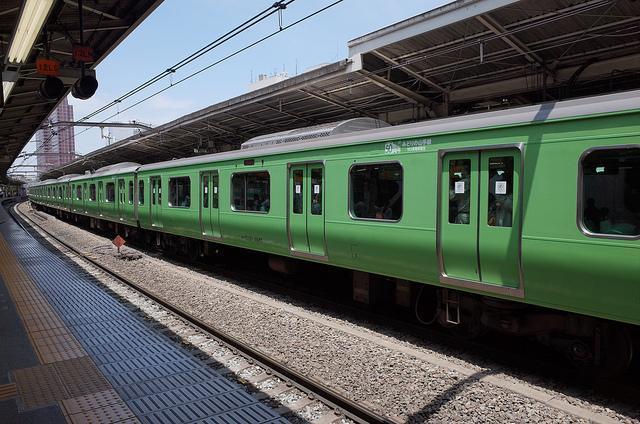How many people can be seen in the picture?
Give a very brief answer. 0. 